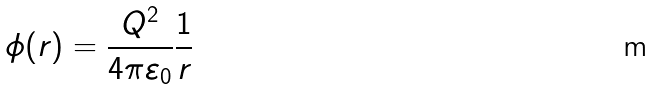<formula> <loc_0><loc_0><loc_500><loc_500>\phi ( r ) = \frac { Q ^ { 2 } } { 4 \pi \varepsilon _ { 0 } } \frac { 1 } { r }</formula> 